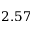Convert formula to latex. <formula><loc_0><loc_0><loc_500><loc_500>2 . 5 7</formula> 